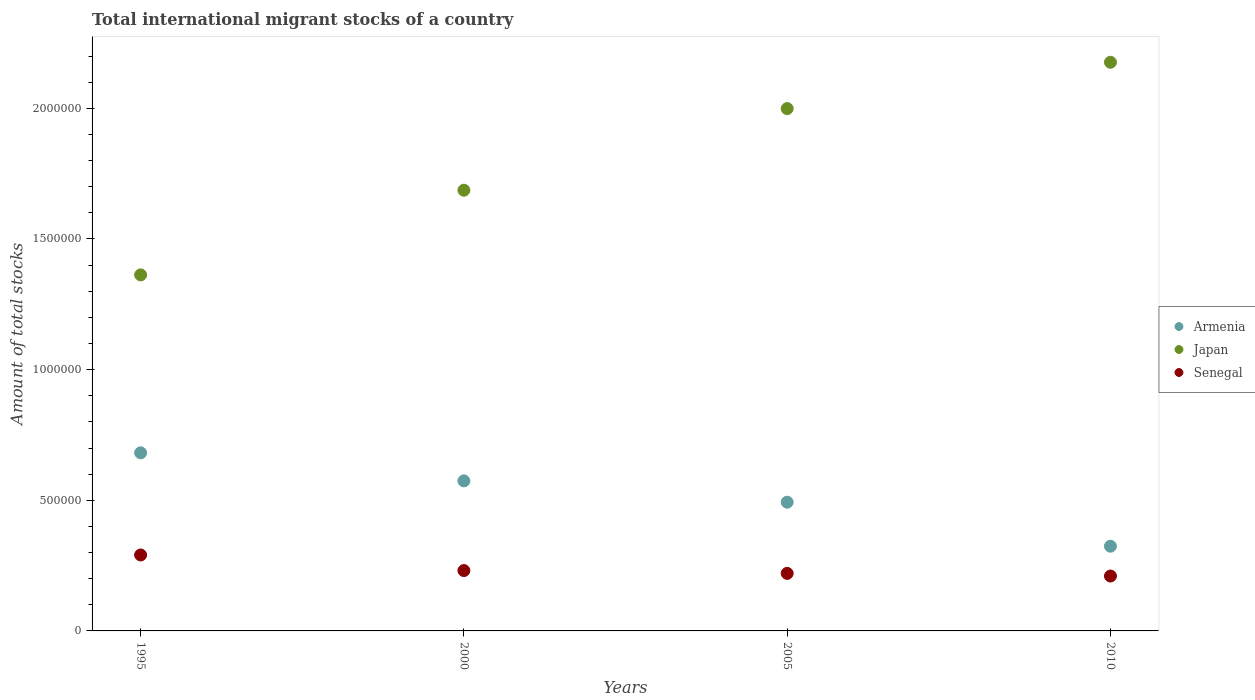How many different coloured dotlines are there?
Offer a terse response. 3. Is the number of dotlines equal to the number of legend labels?
Provide a short and direct response. Yes. What is the amount of total stocks in in Japan in 2010?
Make the answer very short. 2.18e+06. Across all years, what is the maximum amount of total stocks in in Japan?
Offer a very short reply. 2.18e+06. Across all years, what is the minimum amount of total stocks in in Armenia?
Give a very brief answer. 3.24e+05. In which year was the amount of total stocks in in Japan maximum?
Offer a terse response. 2010. In which year was the amount of total stocks in in Japan minimum?
Offer a terse response. 1995. What is the total amount of total stocks in in Armenia in the graph?
Ensure brevity in your answer.  2.07e+06. What is the difference between the amount of total stocks in in Senegal in 2005 and that in 2010?
Your answer should be compact. 1.01e+04. What is the difference between the amount of total stocks in in Japan in 2005 and the amount of total stocks in in Senegal in 2010?
Your answer should be compact. 1.79e+06. What is the average amount of total stocks in in Armenia per year?
Ensure brevity in your answer.  5.18e+05. In the year 2005, what is the difference between the amount of total stocks in in Armenia and amount of total stocks in in Japan?
Make the answer very short. -1.51e+06. What is the ratio of the amount of total stocks in in Japan in 2000 to that in 2005?
Offer a very short reply. 0.84. What is the difference between the highest and the second highest amount of total stocks in in Senegal?
Your response must be concise. 5.97e+04. What is the difference between the highest and the lowest amount of total stocks in in Senegal?
Keep it short and to the point. 8.06e+04. Is the sum of the amount of total stocks in in Senegal in 2005 and 2010 greater than the maximum amount of total stocks in in Armenia across all years?
Provide a short and direct response. No. Is it the case that in every year, the sum of the amount of total stocks in in Senegal and amount of total stocks in in Japan  is greater than the amount of total stocks in in Armenia?
Your response must be concise. Yes. Does the amount of total stocks in in Senegal monotonically increase over the years?
Your response must be concise. No. Is the amount of total stocks in in Japan strictly greater than the amount of total stocks in in Armenia over the years?
Give a very brief answer. Yes. How many dotlines are there?
Offer a terse response. 3. What is the difference between two consecutive major ticks on the Y-axis?
Your response must be concise. 5.00e+05. Does the graph contain grids?
Give a very brief answer. No. Where does the legend appear in the graph?
Your answer should be compact. Center right. How many legend labels are there?
Make the answer very short. 3. What is the title of the graph?
Give a very brief answer. Total international migrant stocks of a country. Does "Guinea" appear as one of the legend labels in the graph?
Make the answer very short. No. What is the label or title of the X-axis?
Your answer should be very brief. Years. What is the label or title of the Y-axis?
Make the answer very short. Amount of total stocks. What is the Amount of total stocks of Armenia in 1995?
Offer a very short reply. 6.82e+05. What is the Amount of total stocks in Japan in 1995?
Offer a terse response. 1.36e+06. What is the Amount of total stocks of Senegal in 1995?
Make the answer very short. 2.91e+05. What is the Amount of total stocks of Armenia in 2000?
Make the answer very short. 5.74e+05. What is the Amount of total stocks of Japan in 2000?
Provide a short and direct response. 1.69e+06. What is the Amount of total stocks in Senegal in 2000?
Your response must be concise. 2.31e+05. What is the Amount of total stocks in Armenia in 2005?
Give a very brief answer. 4.93e+05. What is the Amount of total stocks of Japan in 2005?
Keep it short and to the point. 2.00e+06. What is the Amount of total stocks of Senegal in 2005?
Offer a very short reply. 2.20e+05. What is the Amount of total stocks of Armenia in 2010?
Provide a succinct answer. 3.24e+05. What is the Amount of total stocks in Japan in 2010?
Your answer should be very brief. 2.18e+06. What is the Amount of total stocks in Senegal in 2010?
Your answer should be very brief. 2.10e+05. Across all years, what is the maximum Amount of total stocks in Armenia?
Your response must be concise. 6.82e+05. Across all years, what is the maximum Amount of total stocks in Japan?
Your answer should be very brief. 2.18e+06. Across all years, what is the maximum Amount of total stocks of Senegal?
Your response must be concise. 2.91e+05. Across all years, what is the minimum Amount of total stocks in Armenia?
Make the answer very short. 3.24e+05. Across all years, what is the minimum Amount of total stocks of Japan?
Provide a short and direct response. 1.36e+06. Across all years, what is the minimum Amount of total stocks of Senegal?
Your answer should be very brief. 2.10e+05. What is the total Amount of total stocks in Armenia in the graph?
Ensure brevity in your answer.  2.07e+06. What is the total Amount of total stocks in Japan in the graph?
Provide a short and direct response. 7.22e+06. What is the total Amount of total stocks of Senegal in the graph?
Provide a succinct answer. 9.52e+05. What is the difference between the Amount of total stocks of Armenia in 1995 and that in 2000?
Give a very brief answer. 1.07e+05. What is the difference between the Amount of total stocks in Japan in 1995 and that in 2000?
Keep it short and to the point. -3.24e+05. What is the difference between the Amount of total stocks in Senegal in 1995 and that in 2000?
Provide a succinct answer. 5.97e+04. What is the difference between the Amount of total stocks in Armenia in 1995 and that in 2005?
Make the answer very short. 1.89e+05. What is the difference between the Amount of total stocks in Japan in 1995 and that in 2005?
Your response must be concise. -6.36e+05. What is the difference between the Amount of total stocks of Senegal in 1995 and that in 2005?
Your response must be concise. 7.05e+04. What is the difference between the Amount of total stocks in Armenia in 1995 and that in 2010?
Keep it short and to the point. 3.57e+05. What is the difference between the Amount of total stocks of Japan in 1995 and that in 2010?
Keep it short and to the point. -8.14e+05. What is the difference between the Amount of total stocks in Senegal in 1995 and that in 2010?
Offer a terse response. 8.06e+04. What is the difference between the Amount of total stocks in Armenia in 2000 and that in 2005?
Your answer should be very brief. 8.17e+04. What is the difference between the Amount of total stocks in Japan in 2000 and that in 2005?
Offer a very short reply. -3.12e+05. What is the difference between the Amount of total stocks of Senegal in 2000 and that in 2005?
Keep it short and to the point. 1.08e+04. What is the difference between the Amount of total stocks of Armenia in 2000 and that in 2010?
Make the answer very short. 2.50e+05. What is the difference between the Amount of total stocks of Japan in 2000 and that in 2010?
Your answer should be very brief. -4.90e+05. What is the difference between the Amount of total stocks in Senegal in 2000 and that in 2010?
Keep it short and to the point. 2.10e+04. What is the difference between the Amount of total stocks of Armenia in 2005 and that in 2010?
Your response must be concise. 1.68e+05. What is the difference between the Amount of total stocks of Japan in 2005 and that in 2010?
Offer a very short reply. -1.77e+05. What is the difference between the Amount of total stocks of Senegal in 2005 and that in 2010?
Provide a short and direct response. 1.01e+04. What is the difference between the Amount of total stocks of Armenia in 1995 and the Amount of total stocks of Japan in 2000?
Make the answer very short. -1.01e+06. What is the difference between the Amount of total stocks in Armenia in 1995 and the Amount of total stocks in Senegal in 2000?
Provide a short and direct response. 4.51e+05. What is the difference between the Amount of total stocks of Japan in 1995 and the Amount of total stocks of Senegal in 2000?
Provide a succinct answer. 1.13e+06. What is the difference between the Amount of total stocks of Armenia in 1995 and the Amount of total stocks of Japan in 2005?
Your answer should be compact. -1.32e+06. What is the difference between the Amount of total stocks in Armenia in 1995 and the Amount of total stocks in Senegal in 2005?
Make the answer very short. 4.61e+05. What is the difference between the Amount of total stocks in Japan in 1995 and the Amount of total stocks in Senegal in 2005?
Your answer should be very brief. 1.14e+06. What is the difference between the Amount of total stocks in Armenia in 1995 and the Amount of total stocks in Japan in 2010?
Your answer should be very brief. -1.49e+06. What is the difference between the Amount of total stocks in Armenia in 1995 and the Amount of total stocks in Senegal in 2010?
Your answer should be compact. 4.71e+05. What is the difference between the Amount of total stocks in Japan in 1995 and the Amount of total stocks in Senegal in 2010?
Give a very brief answer. 1.15e+06. What is the difference between the Amount of total stocks in Armenia in 2000 and the Amount of total stocks in Japan in 2005?
Give a very brief answer. -1.42e+06. What is the difference between the Amount of total stocks in Armenia in 2000 and the Amount of total stocks in Senegal in 2005?
Your answer should be very brief. 3.54e+05. What is the difference between the Amount of total stocks of Japan in 2000 and the Amount of total stocks of Senegal in 2005?
Your answer should be very brief. 1.47e+06. What is the difference between the Amount of total stocks in Armenia in 2000 and the Amount of total stocks in Japan in 2010?
Give a very brief answer. -1.60e+06. What is the difference between the Amount of total stocks in Armenia in 2000 and the Amount of total stocks in Senegal in 2010?
Your answer should be very brief. 3.64e+05. What is the difference between the Amount of total stocks of Japan in 2000 and the Amount of total stocks of Senegal in 2010?
Make the answer very short. 1.48e+06. What is the difference between the Amount of total stocks of Armenia in 2005 and the Amount of total stocks of Japan in 2010?
Your answer should be compact. -1.68e+06. What is the difference between the Amount of total stocks in Armenia in 2005 and the Amount of total stocks in Senegal in 2010?
Your response must be concise. 2.83e+05. What is the difference between the Amount of total stocks in Japan in 2005 and the Amount of total stocks in Senegal in 2010?
Offer a terse response. 1.79e+06. What is the average Amount of total stocks in Armenia per year?
Make the answer very short. 5.18e+05. What is the average Amount of total stocks of Japan per year?
Offer a very short reply. 1.81e+06. What is the average Amount of total stocks in Senegal per year?
Make the answer very short. 2.38e+05. In the year 1995, what is the difference between the Amount of total stocks of Armenia and Amount of total stocks of Japan?
Make the answer very short. -6.81e+05. In the year 1995, what is the difference between the Amount of total stocks in Armenia and Amount of total stocks in Senegal?
Keep it short and to the point. 3.91e+05. In the year 1995, what is the difference between the Amount of total stocks in Japan and Amount of total stocks in Senegal?
Provide a short and direct response. 1.07e+06. In the year 2000, what is the difference between the Amount of total stocks in Armenia and Amount of total stocks in Japan?
Provide a succinct answer. -1.11e+06. In the year 2000, what is the difference between the Amount of total stocks of Armenia and Amount of total stocks of Senegal?
Keep it short and to the point. 3.43e+05. In the year 2000, what is the difference between the Amount of total stocks in Japan and Amount of total stocks in Senegal?
Provide a short and direct response. 1.46e+06. In the year 2005, what is the difference between the Amount of total stocks of Armenia and Amount of total stocks of Japan?
Offer a terse response. -1.51e+06. In the year 2005, what is the difference between the Amount of total stocks in Armenia and Amount of total stocks in Senegal?
Keep it short and to the point. 2.72e+05. In the year 2005, what is the difference between the Amount of total stocks of Japan and Amount of total stocks of Senegal?
Provide a short and direct response. 1.78e+06. In the year 2010, what is the difference between the Amount of total stocks in Armenia and Amount of total stocks in Japan?
Your answer should be very brief. -1.85e+06. In the year 2010, what is the difference between the Amount of total stocks in Armenia and Amount of total stocks in Senegal?
Your response must be concise. 1.14e+05. In the year 2010, what is the difference between the Amount of total stocks of Japan and Amount of total stocks of Senegal?
Keep it short and to the point. 1.97e+06. What is the ratio of the Amount of total stocks of Armenia in 1995 to that in 2000?
Your answer should be compact. 1.19. What is the ratio of the Amount of total stocks in Japan in 1995 to that in 2000?
Offer a very short reply. 0.81. What is the ratio of the Amount of total stocks of Senegal in 1995 to that in 2000?
Your answer should be very brief. 1.26. What is the ratio of the Amount of total stocks in Armenia in 1995 to that in 2005?
Provide a succinct answer. 1.38. What is the ratio of the Amount of total stocks in Japan in 1995 to that in 2005?
Offer a very short reply. 0.68. What is the ratio of the Amount of total stocks in Senegal in 1995 to that in 2005?
Offer a terse response. 1.32. What is the ratio of the Amount of total stocks of Armenia in 1995 to that in 2010?
Your response must be concise. 2.1. What is the ratio of the Amount of total stocks of Japan in 1995 to that in 2010?
Your answer should be compact. 0.63. What is the ratio of the Amount of total stocks of Senegal in 1995 to that in 2010?
Provide a short and direct response. 1.38. What is the ratio of the Amount of total stocks in Armenia in 2000 to that in 2005?
Offer a terse response. 1.17. What is the ratio of the Amount of total stocks of Japan in 2000 to that in 2005?
Make the answer very short. 0.84. What is the ratio of the Amount of total stocks of Senegal in 2000 to that in 2005?
Offer a terse response. 1.05. What is the ratio of the Amount of total stocks in Armenia in 2000 to that in 2010?
Your response must be concise. 1.77. What is the ratio of the Amount of total stocks of Japan in 2000 to that in 2010?
Your answer should be compact. 0.78. What is the ratio of the Amount of total stocks of Senegal in 2000 to that in 2010?
Your answer should be compact. 1.1. What is the ratio of the Amount of total stocks of Armenia in 2005 to that in 2010?
Keep it short and to the point. 1.52. What is the ratio of the Amount of total stocks of Japan in 2005 to that in 2010?
Make the answer very short. 0.92. What is the ratio of the Amount of total stocks in Senegal in 2005 to that in 2010?
Make the answer very short. 1.05. What is the difference between the highest and the second highest Amount of total stocks in Armenia?
Your answer should be compact. 1.07e+05. What is the difference between the highest and the second highest Amount of total stocks in Japan?
Make the answer very short. 1.77e+05. What is the difference between the highest and the second highest Amount of total stocks of Senegal?
Provide a succinct answer. 5.97e+04. What is the difference between the highest and the lowest Amount of total stocks of Armenia?
Your response must be concise. 3.57e+05. What is the difference between the highest and the lowest Amount of total stocks in Japan?
Ensure brevity in your answer.  8.14e+05. What is the difference between the highest and the lowest Amount of total stocks in Senegal?
Offer a terse response. 8.06e+04. 